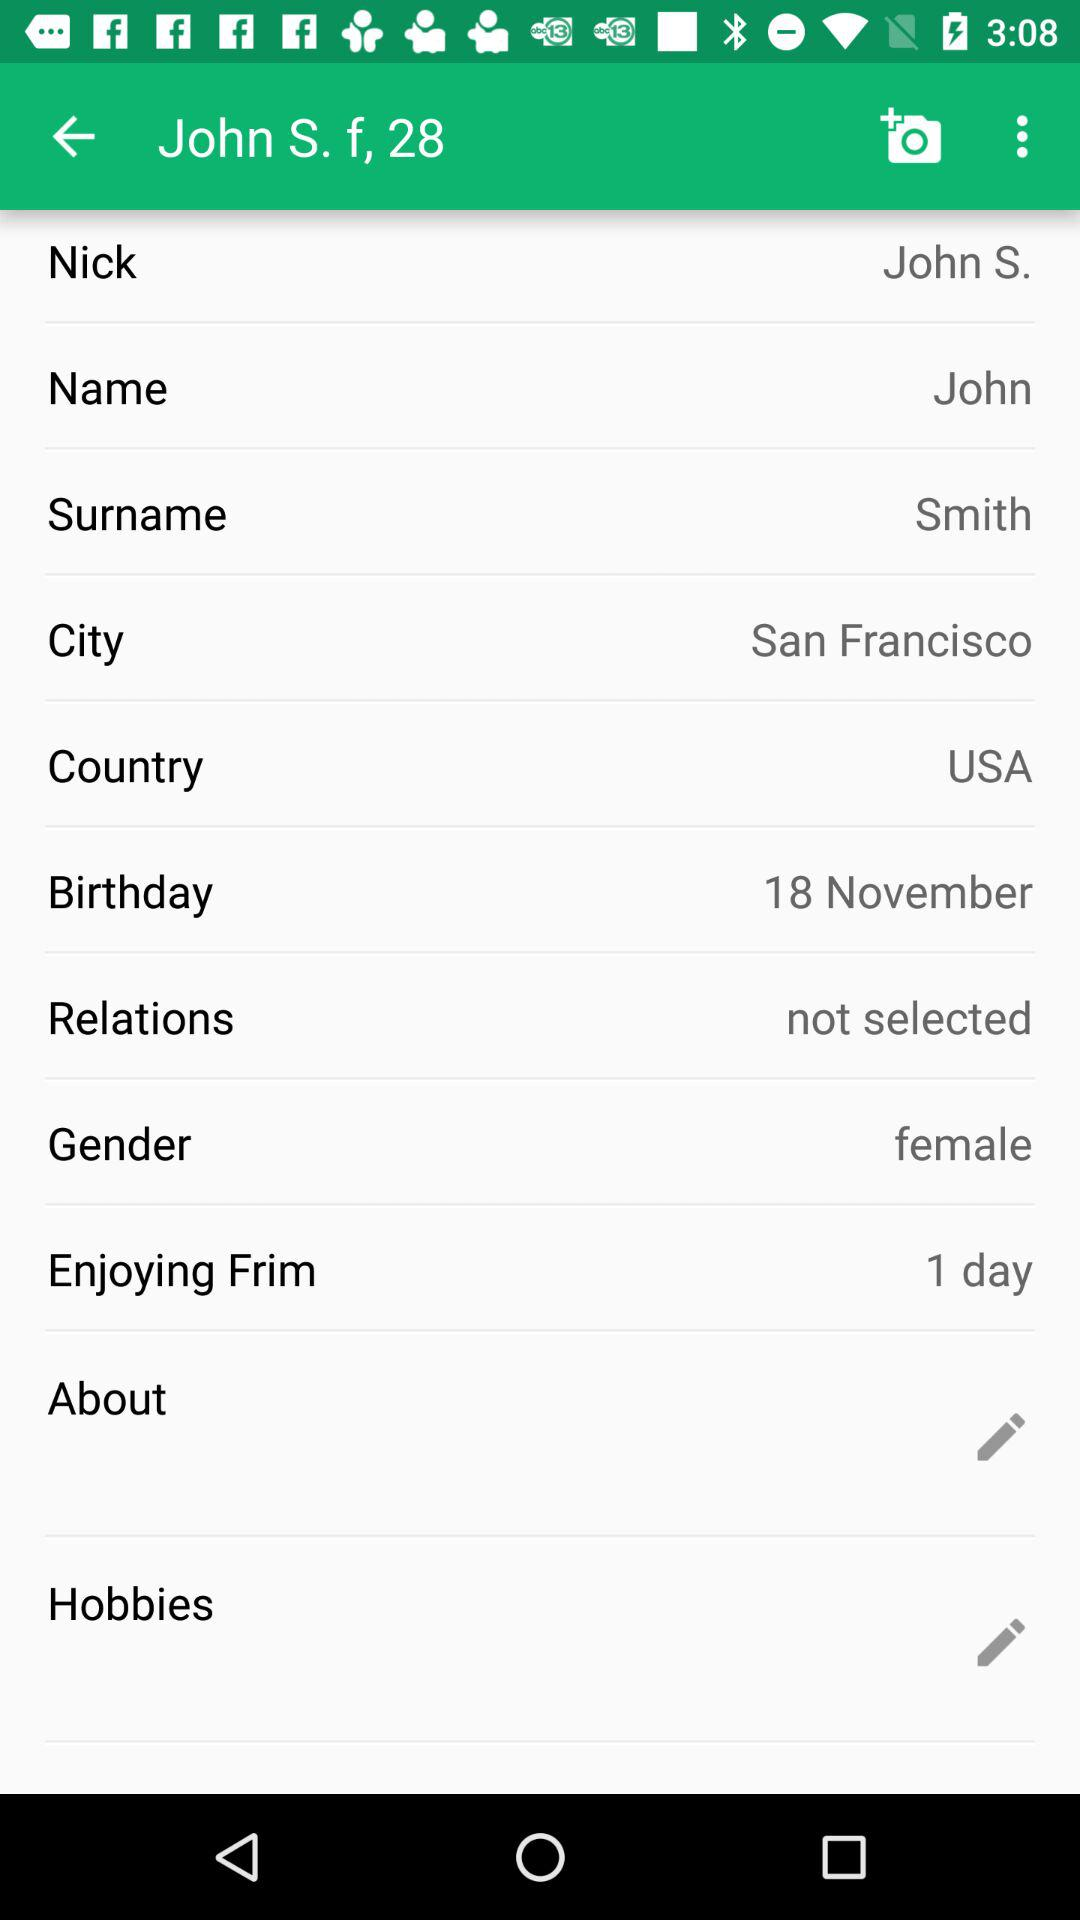Which hobbies are listed?
When the provided information is insufficient, respond with <no answer>. <no answer> 